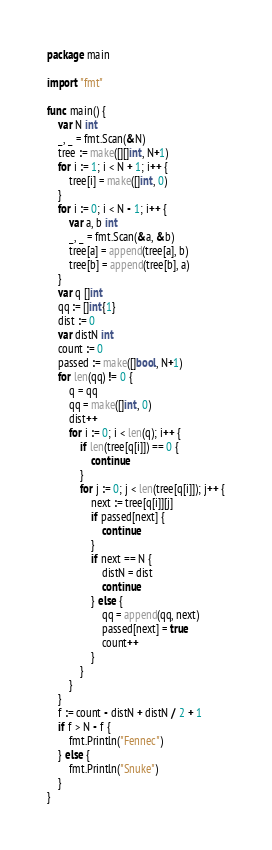<code> <loc_0><loc_0><loc_500><loc_500><_Go_>package main

import "fmt"

func main() {
	var N int
	_, _ = fmt.Scan(&N)
	tree := make([][]int, N+1)
	for i := 1; i < N + 1; i++ {
		tree[i] = make([]int, 0)
	}
	for i := 0; i < N - 1; i++ {
		var a, b int
		_, _ = fmt.Scan(&a, &b)
		tree[a] = append(tree[a], b)
		tree[b] = append(tree[b], a)
	}
	var q []int
	qq := []int{1}
	dist := 0
	var distN int
	count := 0
	passed := make([]bool, N+1)
	for len(qq) != 0 {
		q = qq
		qq = make([]int, 0)
		dist++
		for i := 0; i < len(q); i++ {
			if len(tree[q[i]]) == 0 {
				continue
			}
			for j := 0; j < len(tree[q[i]]); j++ {
				next := tree[q[i]][j]
				if passed[next] {
					continue
				}
				if next == N {
					distN = dist
					continue
				} else {
					qq = append(qq, next)
					passed[next] = true
					count++
				}
			}
		}
	}
	f := count - distN + distN / 2 + 1
	if f > N - f {
		fmt.Println("Fennec")
	} else {
		fmt.Println("Snuke")
	}
}
</code> 